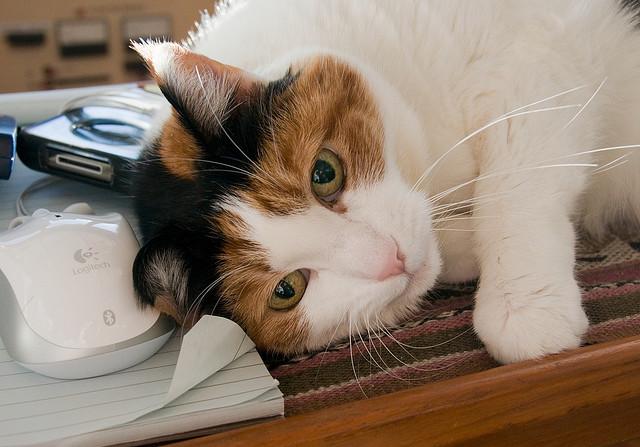What is nearest the camera on the table?
Answer briefly. Cat. Is there a notepad in the picture?
Be succinct. Yes. What brand mouse is this?
Write a very short answer. Logitech. What is the cat's paw resting on?
Short answer required. Table. What is this animal?
Short answer required. Cat. Is the mouse wireless?
Keep it brief. No. 